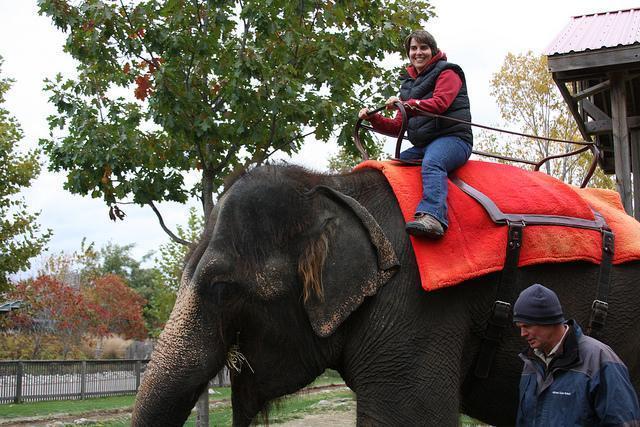How many people can be seen?
Give a very brief answer. 2. How many of the airplanes have entrails?
Give a very brief answer. 0. 